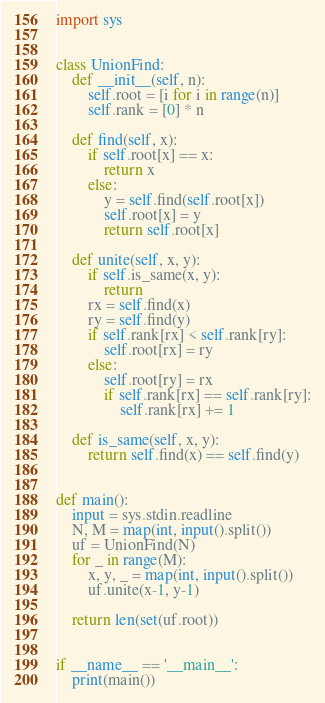<code> <loc_0><loc_0><loc_500><loc_500><_Python_>import sys


class UnionFind:
    def __init__(self, n):
        self.root = [i for i in range(n)]
        self.rank = [0] * n

    def find(self, x):
        if self.root[x] == x:
            return x
        else:
            y = self.find(self.root[x])
            self.root[x] = y
            return self.root[x]

    def unite(self, x, y):
        if self.is_same(x, y):
            return
        rx = self.find(x)
        ry = self.find(y)
        if self.rank[rx] < self.rank[ry]:
            self.root[rx] = ry
        else:
            self.root[ry] = rx
            if self.rank[rx] == self.rank[ry]:
                self.rank[rx] += 1

    def is_same(self, x, y):
        return self.find(x) == self.find(y)
    

def main():
    input = sys.stdin.readline
    N, M = map(int, input().split())
    uf = UnionFind(N)
    for _ in range(M):
        x, y, _ = map(int, input().split())
        uf.unite(x-1, y-1)

    return len(set(uf.root))


if __name__ == '__main__':
    print(main())
</code> 